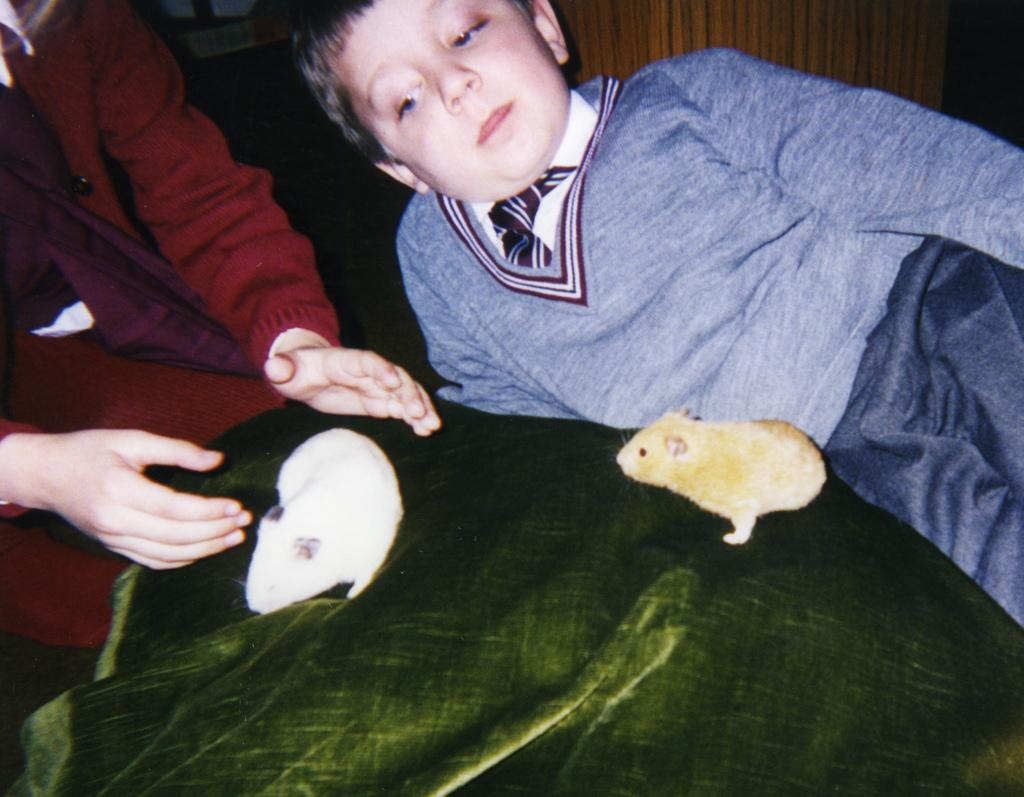What is the main subject of the image? The main subject of the image is a kid. Can you describe the person sitting in the image? There is a person sitting on the left side of the image. What other living creatures are present in the image? There are two small animals in the image. What type of peace symbol can be seen in the image? There is no peace symbol present in the image. Can you describe the ball that the kid is playing with in the image? There is no ball present in the image. 